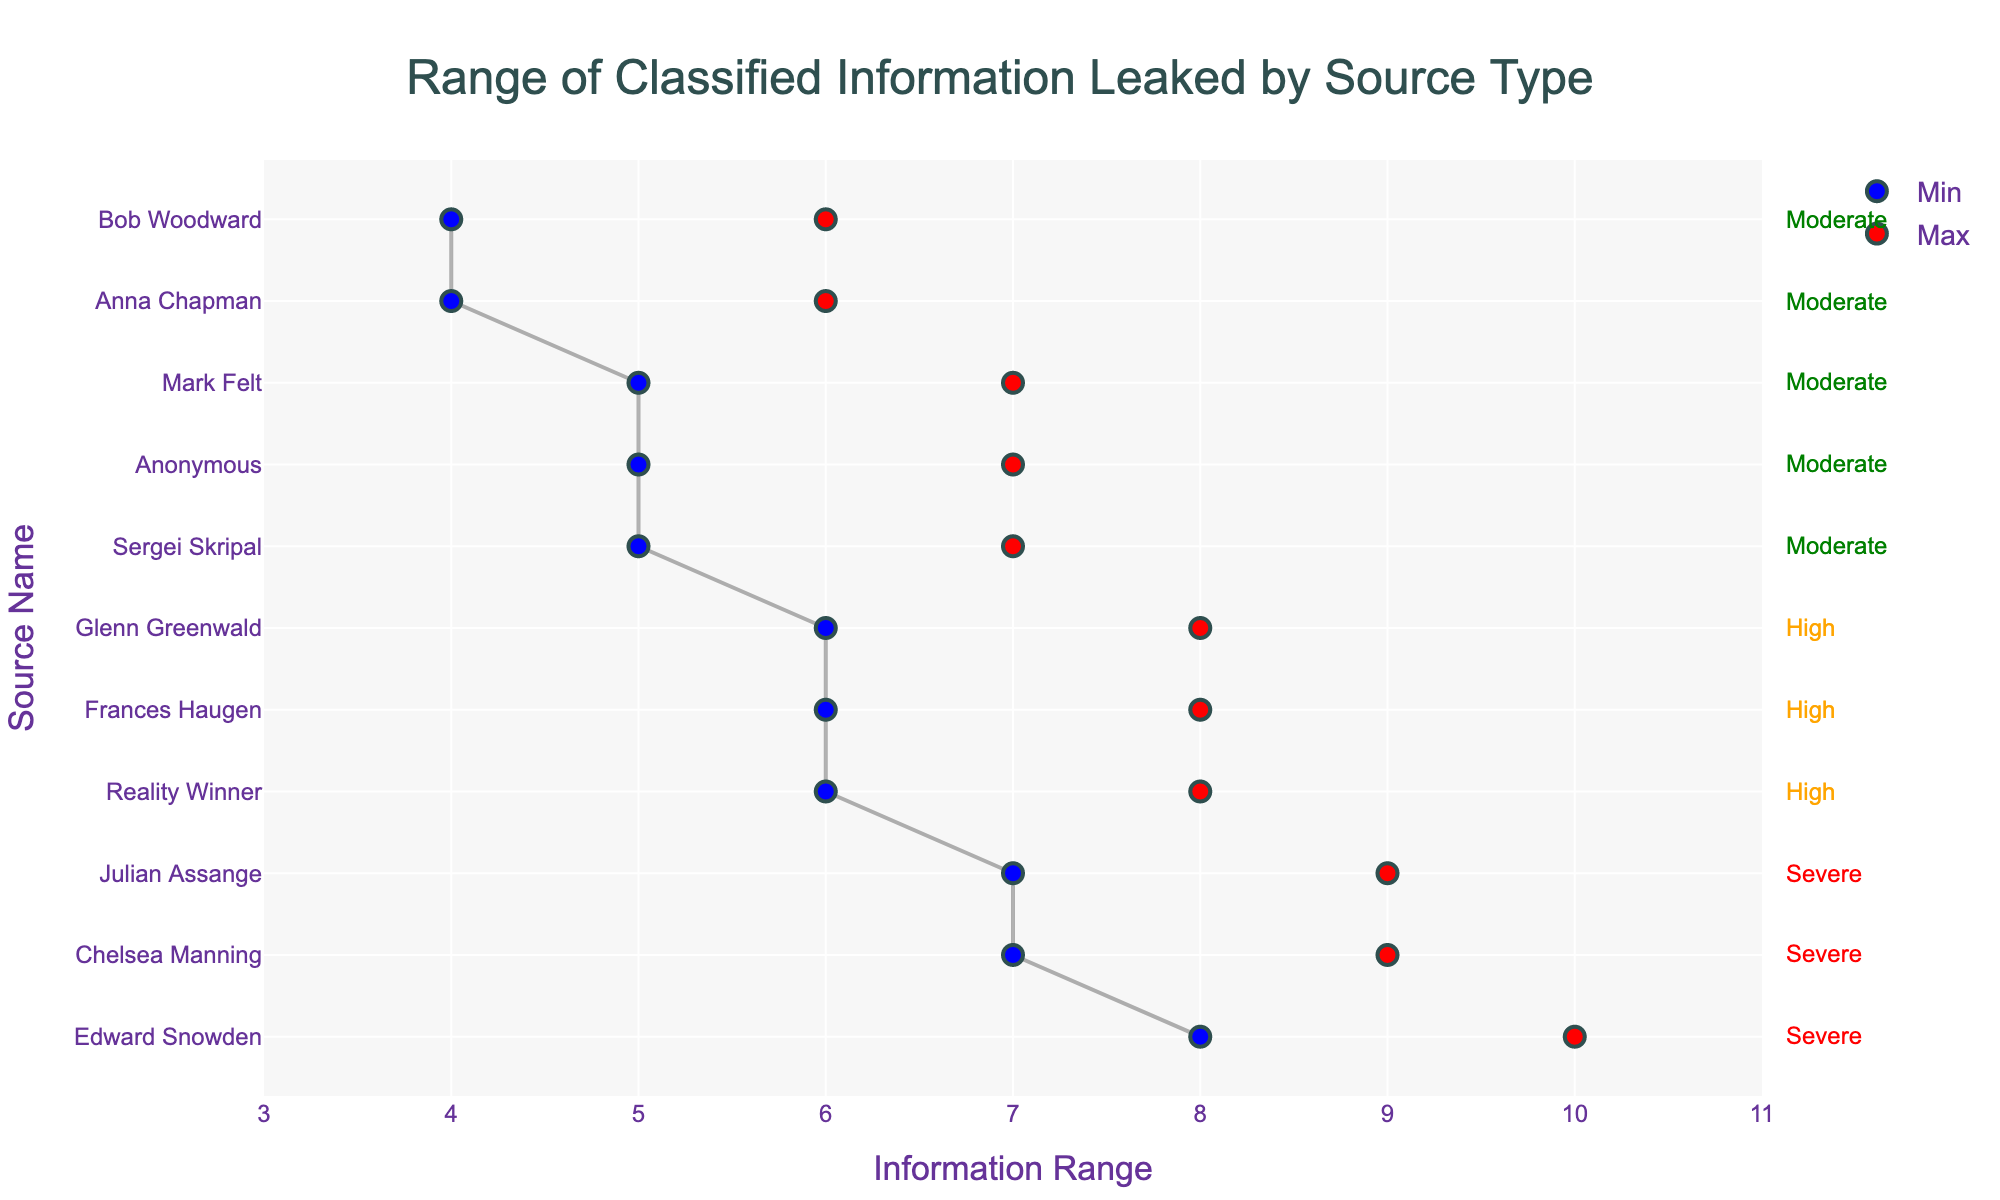What is the title of the figure? The title of the figure is located at the top center of the plot. It provides a description of what the plot represents.
Answer: Range of Classified Information Leaked by Source Type Which source type has the highest range maximum value, and what is that value? By looking at the red dots which represent the maximum values, identify the source type with the highest red dot position.
Answer: Insider, 10 What is the total number of sources represented in the plot? Count the unique source names along the y-axis.
Answer: 11 Which risk level is most frequently associated with the sources? Count the frequency of each risk level annotation (Severe, High, Moderate) along the right side of the plot.
Answer: Moderate What are the range minimum and maximum values for Julian Assange? Locate Julian Assange along the y-axis and examine the corresponding blue and red dots for the range values.
Answer: 7 and 9 Which source has the narrowest range of leaked classified information? Identify and compare the length of the lines (distance between blue and red dots) for each source.
Answer: Bob Woodward What is the average risk level for Insider sources? List the Risk Levels for all 'Insider' sources and convert to a numerical scale (e.g., Severe=3, High=2, Moderate=1), then calculate the average.
Answer: 2.67 (Severe:3, High:2, Moderate:1) Which two sources have the same range of 6 to 8? Look for blue and red dots that mark the start at 6 and end at 8 along the x-axis, then identify the corresponding y-axis (source names).
Answer: Reality Winner, Glenn Greenwald What is the difference between the minimum values of Sergei Skripal and Mark Felt? Locate the blue dots for Sergei Skripal and Mark Felt, note their positions on the x-axis, and calculate the difference.
Answer: 5 - 5 = 0 Which source was categorized as having a 'High' risk level and deals with social media algorithms? Look through the list of sources with 'High' risk levels on the right side, then cross-reference with the information category.
Answer: Frances Haugen 